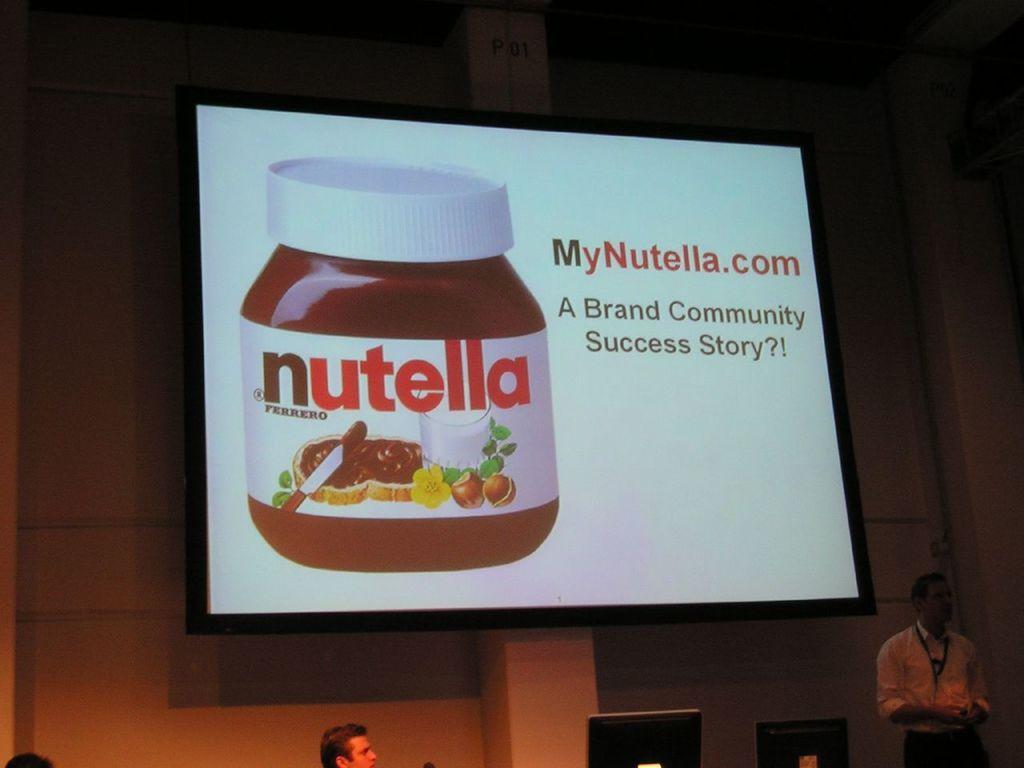Describe this image in one or two sentences. In this image there is a screen hanging on the wall. On the screen we can see there is an image of a bottle, beside that there is some text. Below the screen there are few people, in front the people there are few monitors and on the right side there is a person standing. 